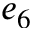<formula> <loc_0><loc_0><loc_500><loc_500>e _ { 6 }</formula> 